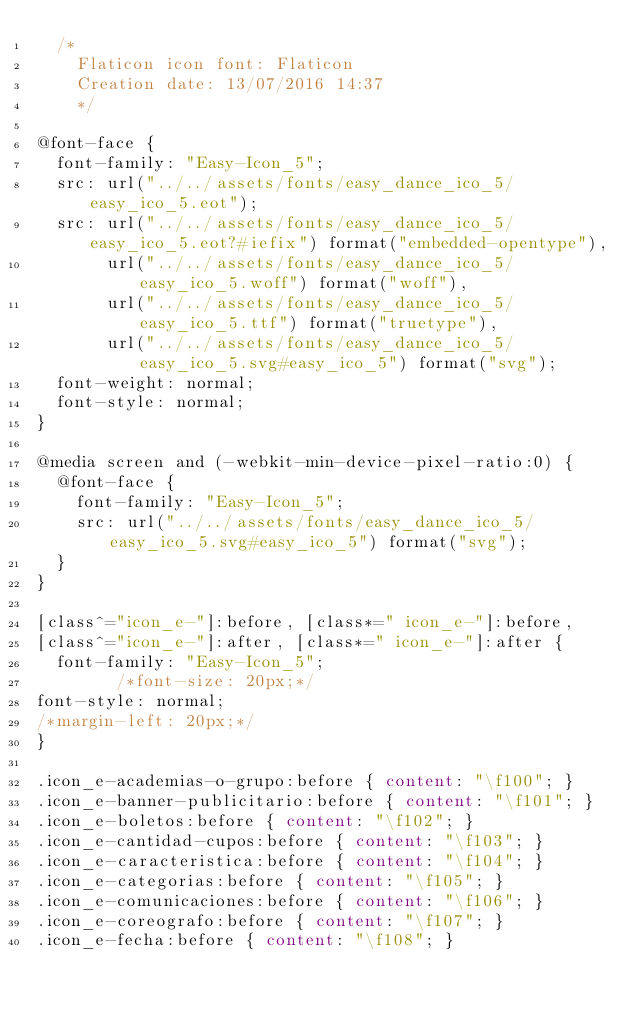<code> <loc_0><loc_0><loc_500><loc_500><_CSS_>	/*
  	Flaticon icon font: Flaticon
  	Creation date: 13/07/2016 14:37
  	*/

@font-face {
  font-family: "Easy-Icon_5";
  src: url("../../assets/fonts/easy_dance_ico_5/easy_ico_5.eot");
  src: url("../../assets/fonts/easy_dance_ico_5/easy_ico_5.eot?#iefix") format("embedded-opentype"),
       url("../../assets/fonts/easy_dance_ico_5/easy_ico_5.woff") format("woff"),
       url("../../assets/fonts/easy_dance_ico_5/easy_ico_5.ttf") format("truetype"),
       url("../../assets/fonts/easy_dance_ico_5/easy_ico_5.svg#easy_ico_5") format("svg");
  font-weight: normal;
  font-style: normal;
}

@media screen and (-webkit-min-device-pixel-ratio:0) {
  @font-face {
    font-family: "Easy-Icon_5";
    src: url("../../assets/fonts/easy_dance_ico_5/easy_ico_5.svg#easy_ico_5") format("svg");
  }
}

[class^="icon_e-"]:before, [class*=" icon_e-"]:before,
[class^="icon_e-"]:after, [class*=" icon_e-"]:after {   
  font-family: "Easy-Icon_5";
        /*font-size: 20px;*/
font-style: normal;
/*margin-left: 20px;*/
}

.icon_e-academias-o-grupo:before { content: "\f100"; }
.icon_e-banner-publicitario:before { content: "\f101"; }
.icon_e-boletos:before { content: "\f102"; }
.icon_e-cantidad-cupos:before { content: "\f103"; }
.icon_e-caracteristica:before { content: "\f104"; }
.icon_e-categorias:before { content: "\f105"; }
.icon_e-comunicaciones:before { content: "\f106"; }
.icon_e-coreografo:before { content: "\f107"; }
.icon_e-fecha:before { content: "\f108"; }</code> 